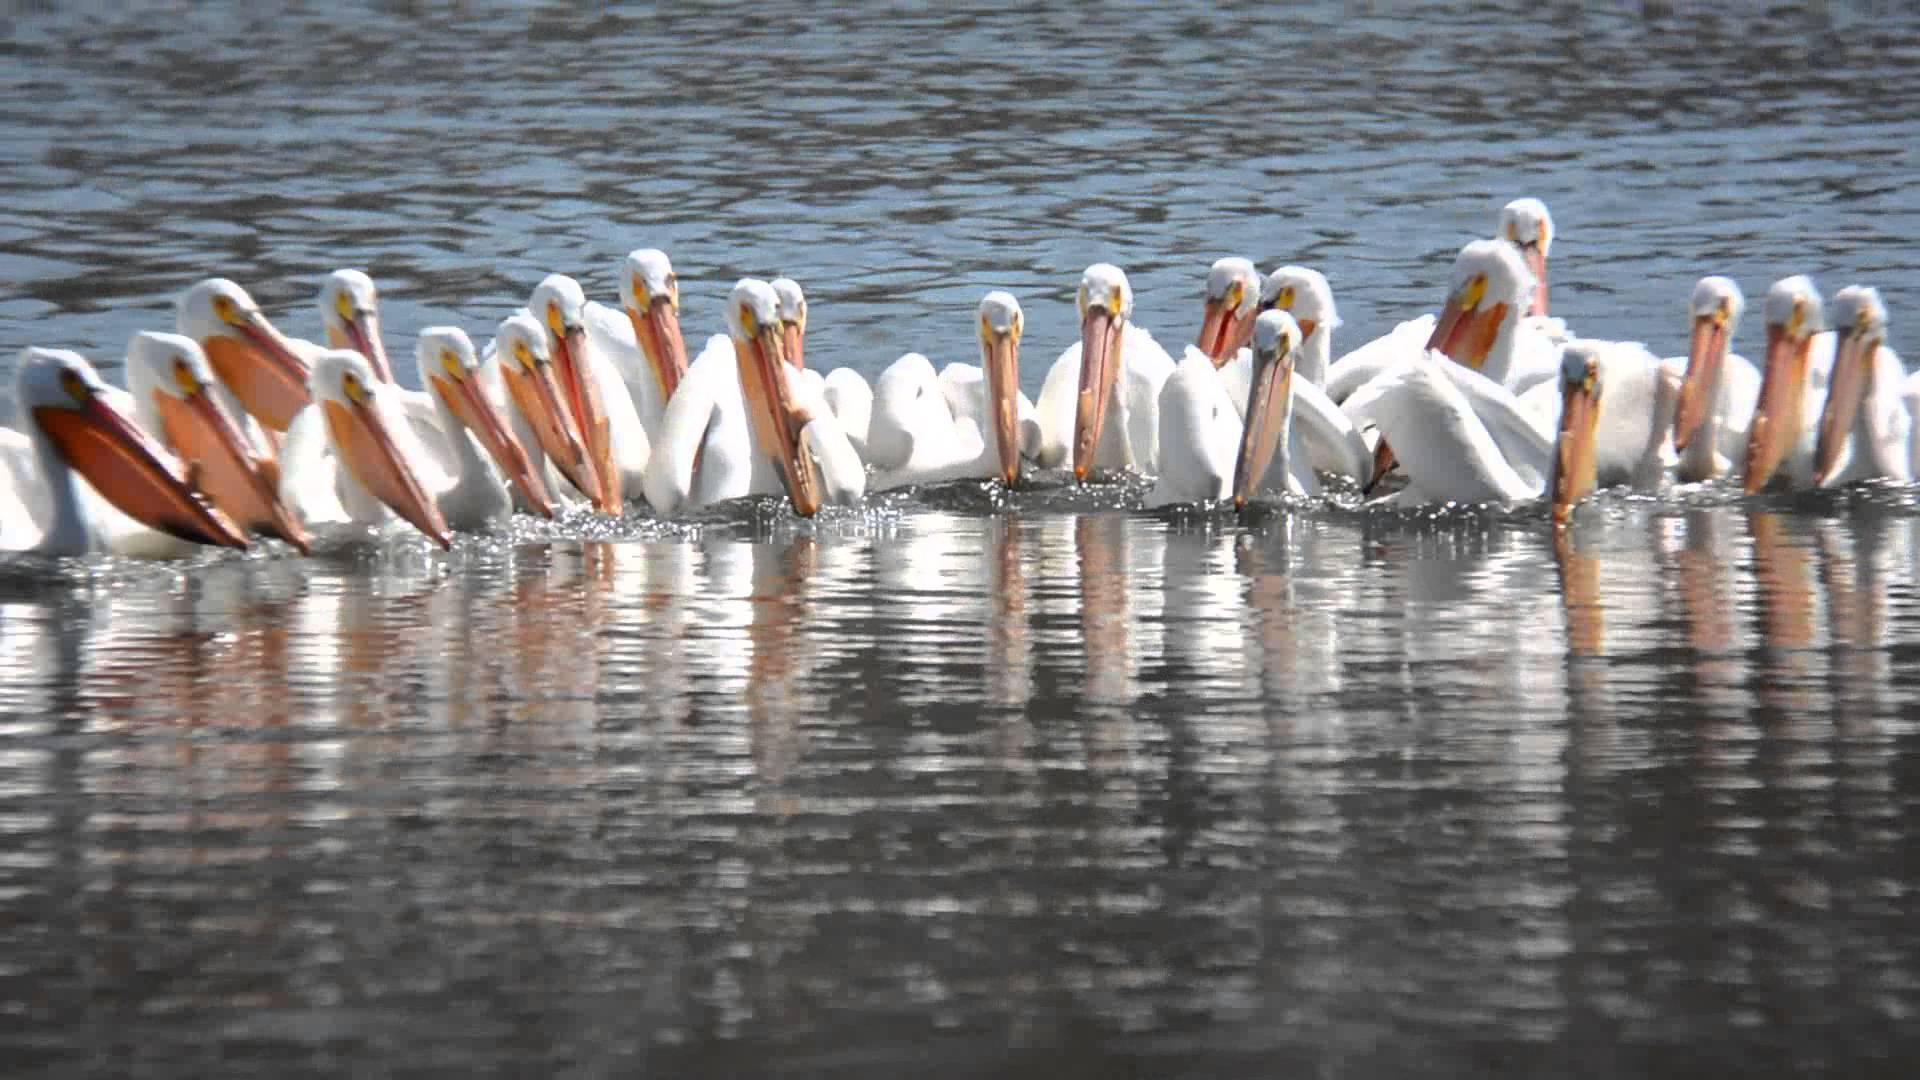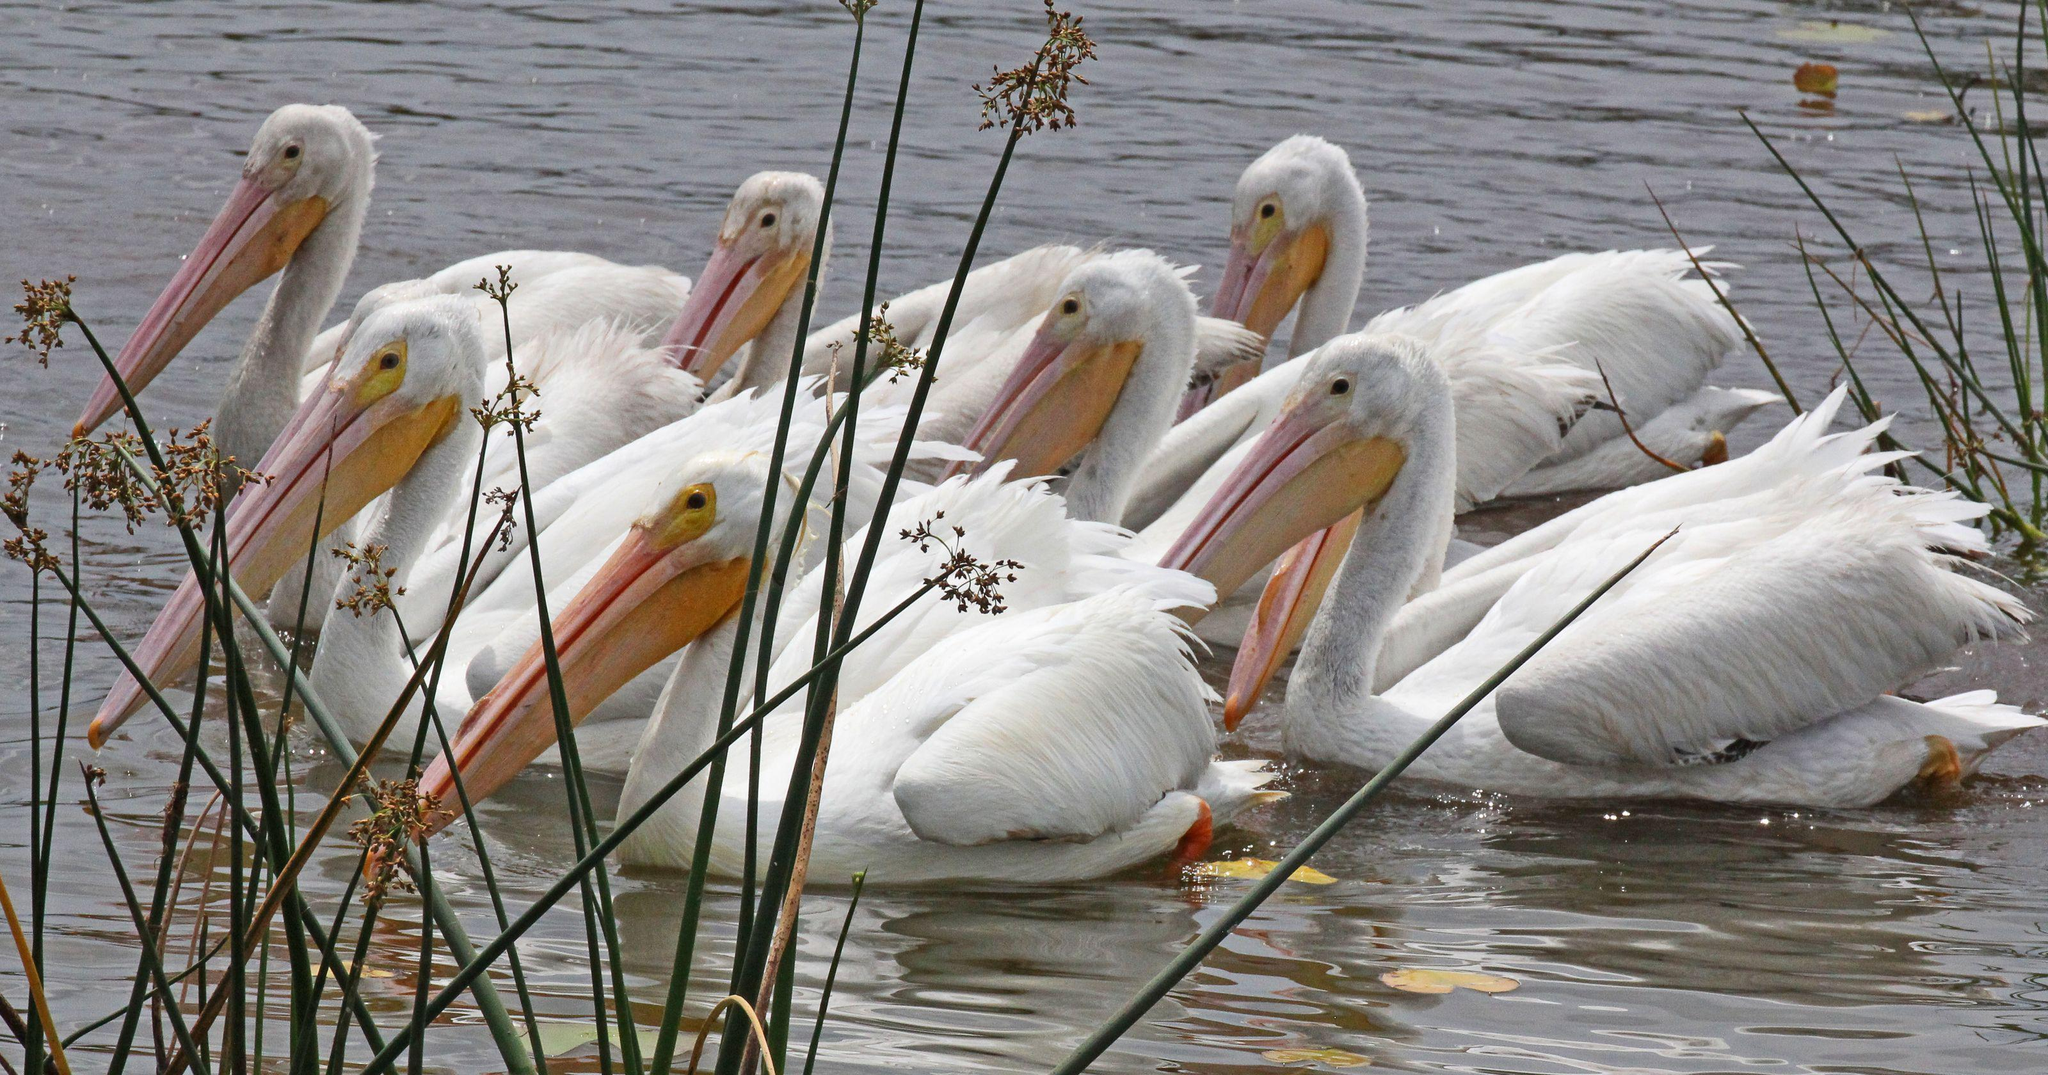The first image is the image on the left, the second image is the image on the right. Analyze the images presented: Is the assertion "there are pelicans in the image on the left" valid? Answer yes or no. Yes. The first image is the image on the left, the second image is the image on the right. Considering the images on both sides, is "In one image, pink flamingos are amassed in water." valid? Answer yes or no. No. 